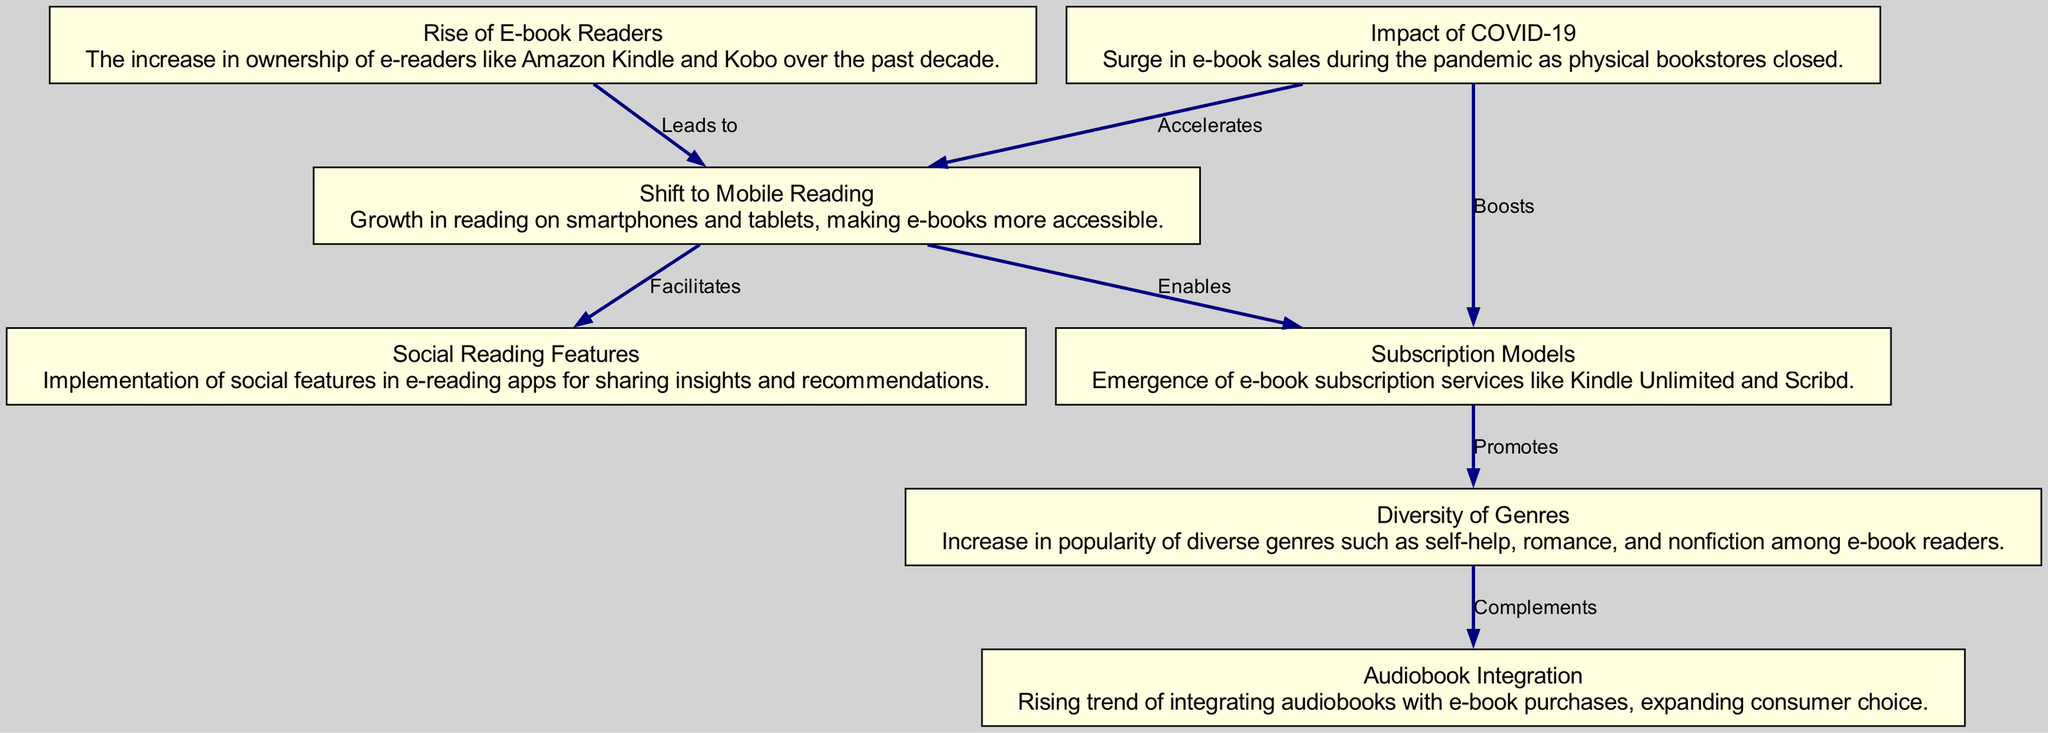What is the total number of nodes in the diagram? The diagram consists of 7 distinct nodes, each representing a key market trend in e-book sales over the last decade.
Answer: 7 What is the name of the node that represents the growth in mobile reading? The node representing growth in mobile reading is labeled "Shift to Mobile Reading."
Answer: Shift to Mobile Reading Which trend promotes the diversity of genres? The "Subscription Models" node promotes diversity in genres as viewed from its outgoing connection to the "Diversity of Genres" node.
Answer: Subscription Models What relationship does "Impact of COVID-19" have with "Shift to Mobile Reading"? The "Impact of COVID-19" node accelerates the trend represented by the "Shift to Mobile Reading" node as indicated by the directed edge between them.
Answer: Accelerates What is the main factor that boosts subscription models according to the diagram? The main factor boosting subscription models is the surge caused by the "Impact of COVID-19," as shown by the directed edge connecting these two nodes.
Answer: Impact of COVID-19 Which two trends facilitate social reading features? The "Shift to Mobile Reading" and the "Subscription Models" nodes both facilitate social reading features, as they direct to the "Social Reading Features" node.
Answer: Shift to Mobile Reading, Subscription Models What is the connecting relationship between "Diversity of Genres" and "Audiobook Integration"? The "Diversity of Genres" node complements the "Audiobook Integration" node, indicating that a wider variety of genres enhances audiobook choices.
Answer: Complements How many edges are represented in the diagram? The diagram contains 7 edges, each representing a relationship between the various trends in e-book sales.
Answer: 7 Which node identifies the trend arising from the pandemic? The "Impact of COVID-19" node identifies the trend that arose due to the pandemic's influence on the e-book market.
Answer: Impact of COVID-19 